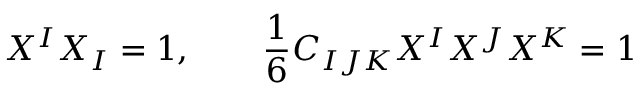Convert formula to latex. <formula><loc_0><loc_0><loc_500><loc_500>X ^ { I } X _ { I } = 1 , \quad { \frac { 1 } { 6 } } C _ { I J K } X ^ { I } X ^ { J } X ^ { K } = 1</formula> 